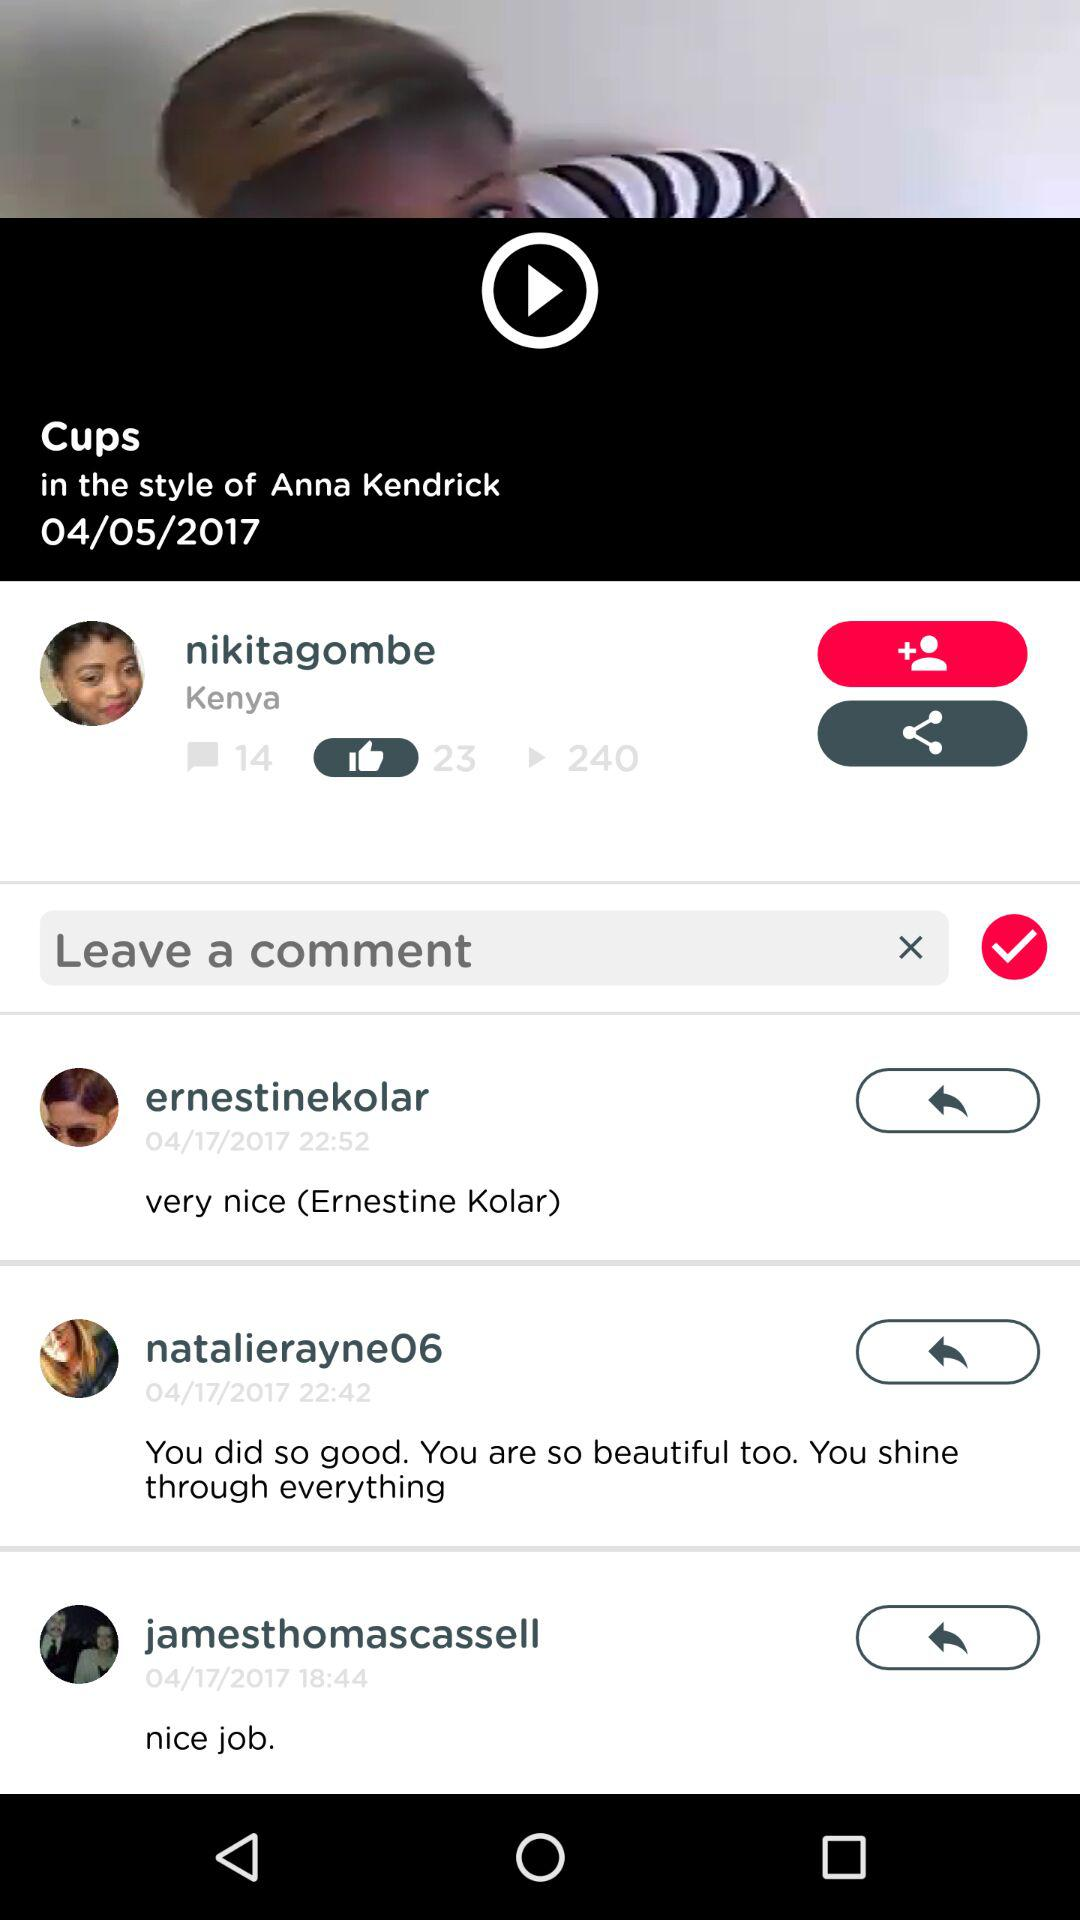What is the given country? The given country is Kenya. 